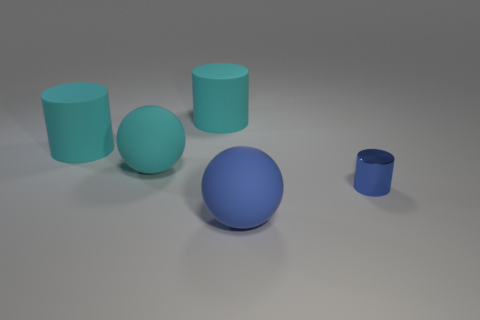Add 4 cylinders. How many objects exist? 9 Subtract all spheres. How many objects are left? 3 Add 3 cylinders. How many cylinders are left? 6 Add 3 large cyan spheres. How many large cyan spheres exist? 4 Subtract 1 cyan cylinders. How many objects are left? 4 Subtract all blue cylinders. Subtract all rubber cylinders. How many objects are left? 2 